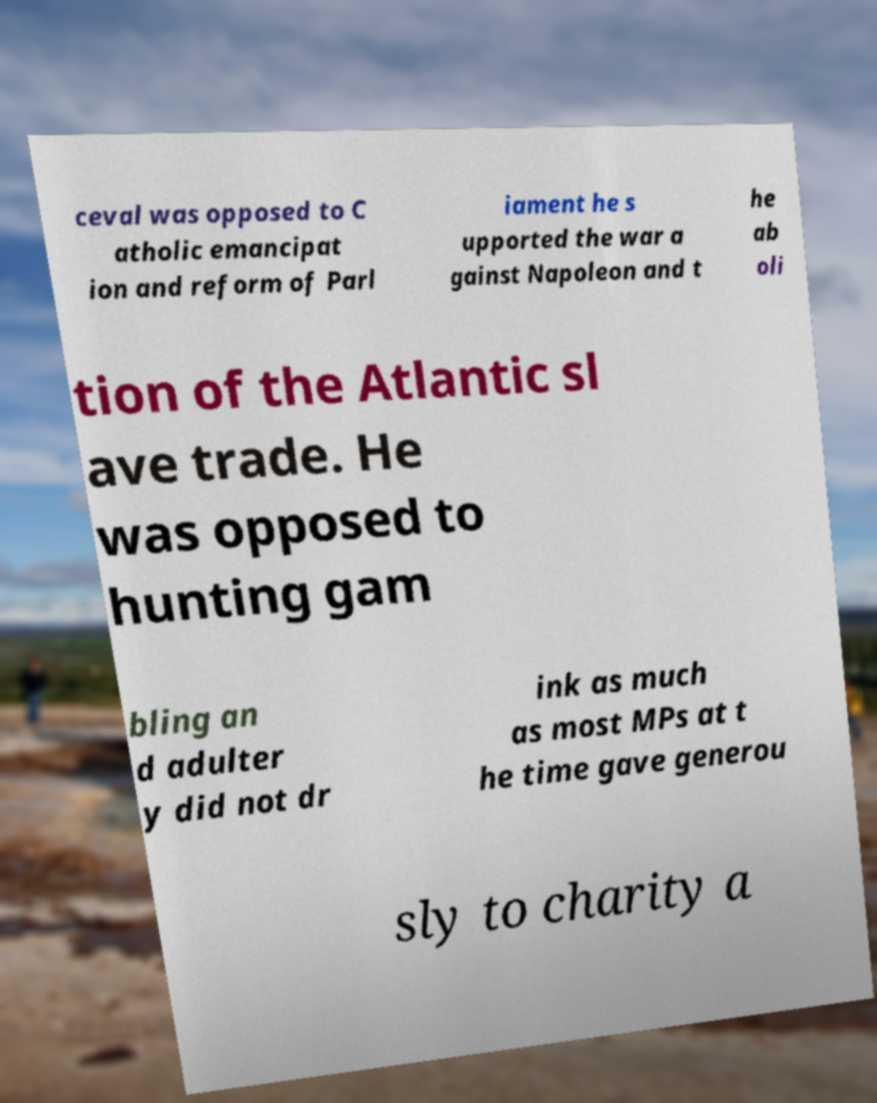For documentation purposes, I need the text within this image transcribed. Could you provide that? ceval was opposed to C atholic emancipat ion and reform of Parl iament he s upported the war a gainst Napoleon and t he ab oli tion of the Atlantic sl ave trade. He was opposed to hunting gam bling an d adulter y did not dr ink as much as most MPs at t he time gave generou sly to charity a 